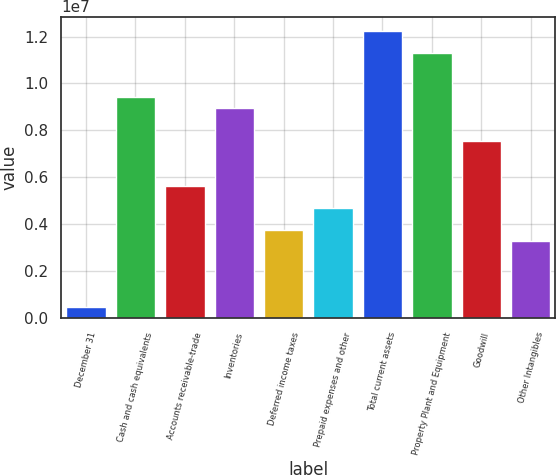<chart> <loc_0><loc_0><loc_500><loc_500><bar_chart><fcel>December 31<fcel>Cash and cash equivalents<fcel>Accounts receivable-trade<fcel>Inventories<fcel>Deferred income taxes<fcel>Prepaid expenses and other<fcel>Total current assets<fcel>Property Plant and Equipment<fcel>Goodwill<fcel>Other Intangibles<nl><fcel>472498<fcel>9.41388e+06<fcel>5.64909e+06<fcel>8.94329e+06<fcel>3.76669e+06<fcel>4.70789e+06<fcel>1.22375e+07<fcel>1.12963e+07<fcel>7.53149e+06<fcel>3.29609e+06<nl></chart> 